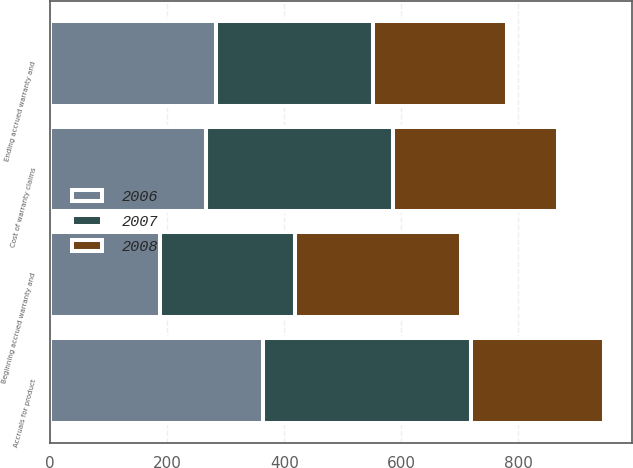Convert chart to OTSL. <chart><loc_0><loc_0><loc_500><loc_500><stacked_bar_chart><ecel><fcel>Beginning accrued warranty and<fcel>Cost of warranty claims<fcel>Accruals for product<fcel>Ending accrued warranty and<nl><fcel>2007<fcel>230<fcel>319<fcel>356<fcel>267<nl><fcel>2008<fcel>284<fcel>281<fcel>227<fcel>230<nl><fcel>2006<fcel>188<fcel>267<fcel>363<fcel>284<nl></chart> 